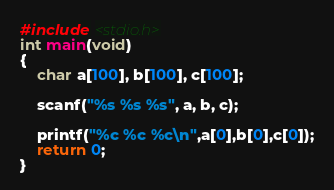<code> <loc_0><loc_0><loc_500><loc_500><_C_>#include <stdio.h>
int main(void)
{
    char a[100], b[100], c[100];

    scanf("%s %s %s", a, b, c);

    printf("%c %c %c\n",a[0],b[0],c[0]);
    return 0;
}</code> 